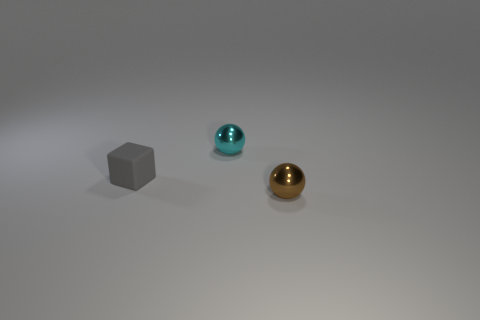Is there anything else that has the same material as the block?
Provide a short and direct response. No. Is the number of gray rubber cubes that are in front of the small gray matte thing the same as the number of blue metallic cylinders?
Give a very brief answer. Yes. There is another metal thing that is the same shape as the cyan shiny object; what color is it?
Your response must be concise. Brown. How many large red objects have the same shape as the cyan thing?
Offer a very short reply. 0. What number of big red cubes are there?
Your answer should be very brief. 0. Is there a brown sphere that has the same material as the brown object?
Keep it short and to the point. No. Does the cyan thing to the left of the brown object have the same size as the sphere in front of the gray block?
Ensure brevity in your answer.  Yes. What size is the metal sphere in front of the gray rubber thing?
Make the answer very short. Small. Are there any tiny objects that have the same color as the small matte block?
Offer a very short reply. No. There is a tiny sphere that is in front of the small rubber cube; is there a gray rubber thing that is on the right side of it?
Give a very brief answer. No. 